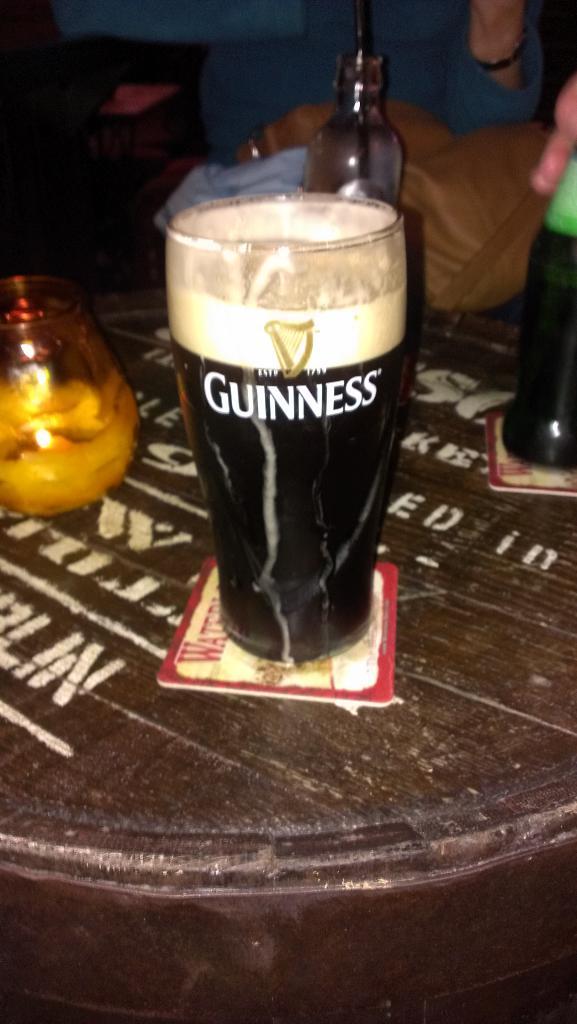What type of beer is on the glass?
Give a very brief answer. Guinness. 